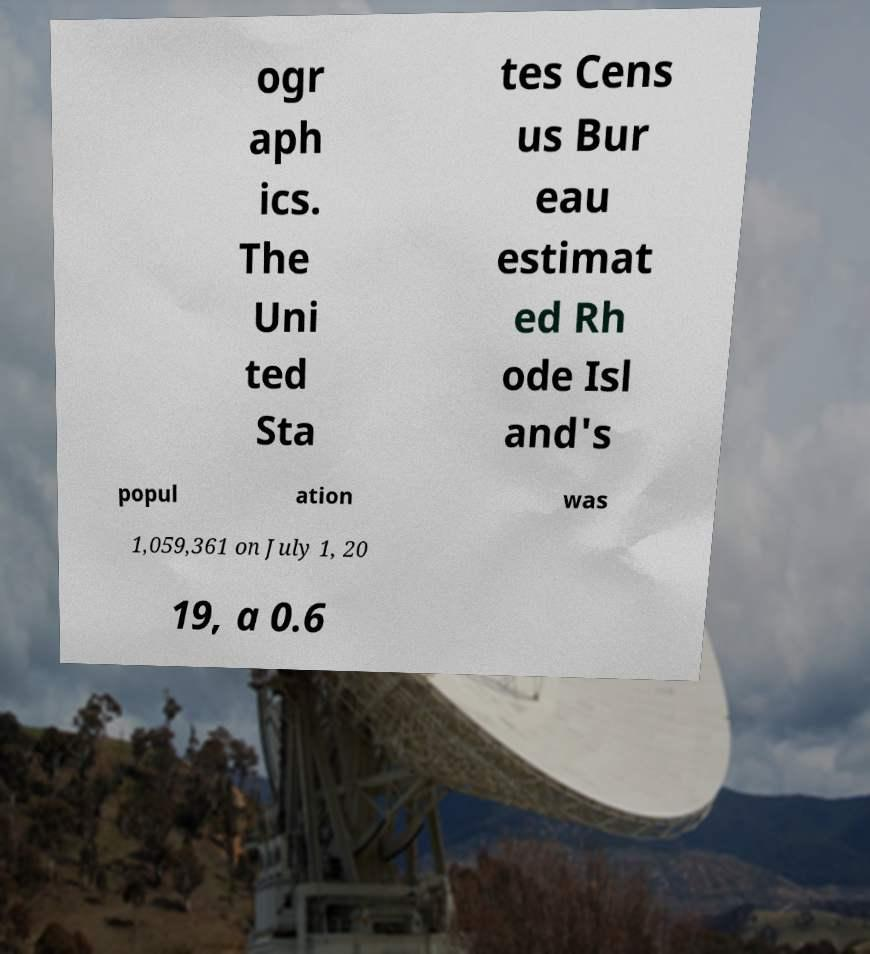For documentation purposes, I need the text within this image transcribed. Could you provide that? ogr aph ics. The Uni ted Sta tes Cens us Bur eau estimat ed Rh ode Isl and's popul ation was 1,059,361 on July 1, 20 19, a 0.6 